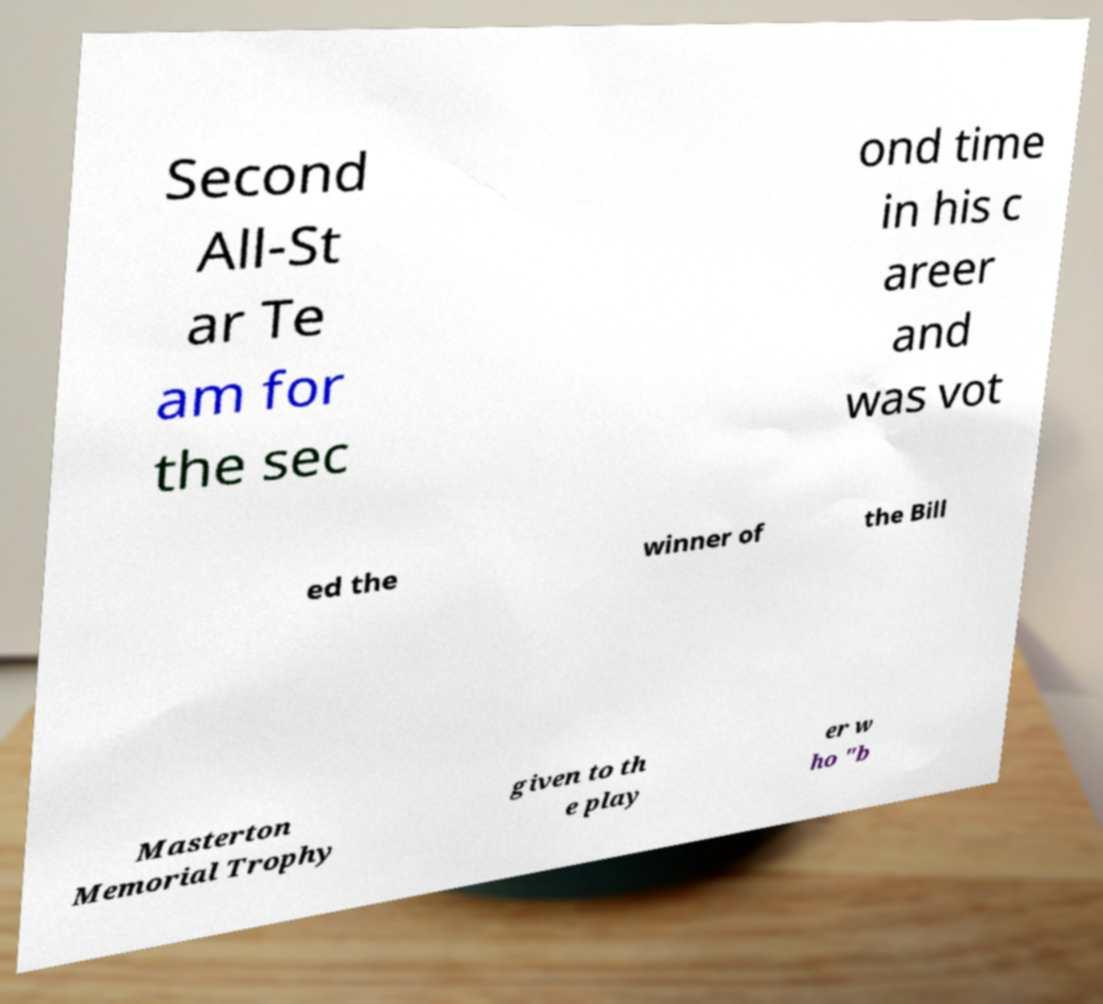Could you extract and type out the text from this image? Second All-St ar Te am for the sec ond time in his c areer and was vot ed the winner of the Bill Masterton Memorial Trophy given to th e play er w ho "b 